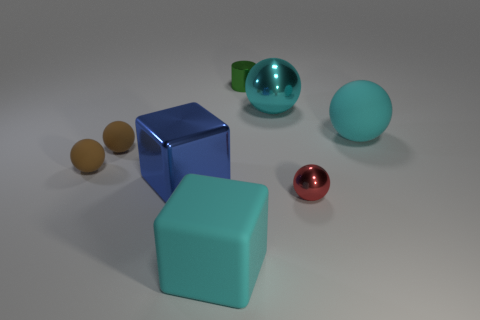There is a metal object that is the same size as the red metallic sphere; what color is it?
Provide a succinct answer. Green. Is the number of big objects on the right side of the cyan matte cube less than the number of metal things to the left of the red ball?
Provide a short and direct response. Yes. There is a big matte object behind the cyan cube that is in front of the blue cube; what number of small objects are left of it?
Provide a succinct answer. 4. The other metallic object that is the same shape as the big cyan metal object is what size?
Give a very brief answer. Small. Is the small red shiny thing the same shape as the cyan metal object?
Give a very brief answer. Yes. The other big object that is the same shape as the large blue object is what color?
Ensure brevity in your answer.  Cyan. How many tiny shiny balls have the same color as the metal cube?
Your response must be concise. 0. What number of objects are balls on the left side of the cylinder or brown rubber balls?
Give a very brief answer. 2. What size is the red metallic ball that is to the right of the big blue object?
Your answer should be compact. Small. Are there fewer metal objects than large cyan spheres?
Provide a succinct answer. No. 